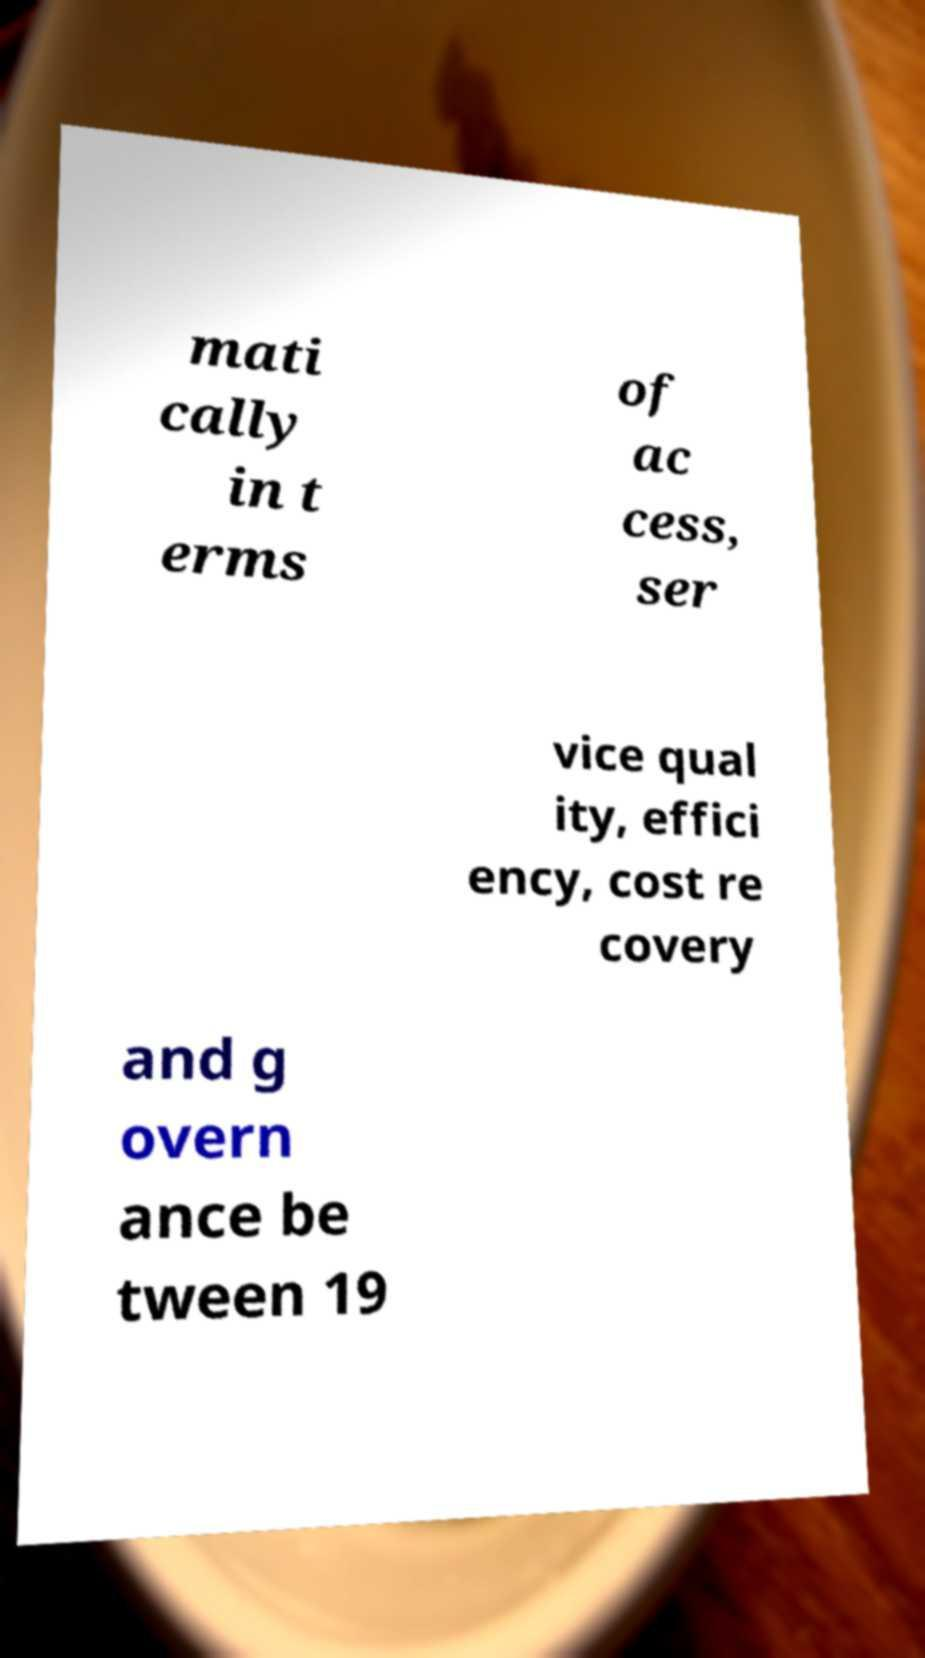Could you assist in decoding the text presented in this image and type it out clearly? mati cally in t erms of ac cess, ser vice qual ity, effici ency, cost re covery and g overn ance be tween 19 